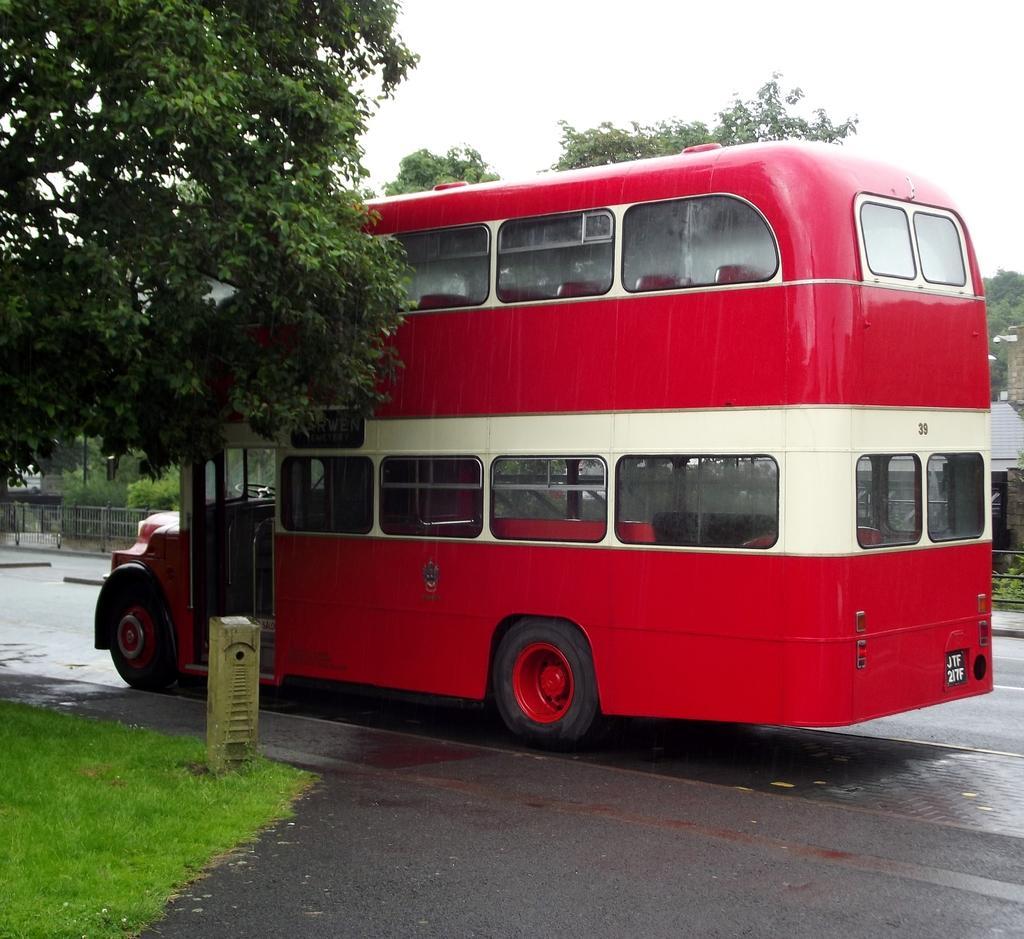Please provide a concise description of this image. In this image there is a bus on the road. On the left side of the image there is a grass on the surface. Behind the bus there is a metal fence. In the background of the image there are trees, buildings and sky. 